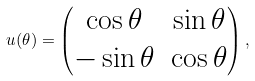Convert formula to latex. <formula><loc_0><loc_0><loc_500><loc_500>u ( \theta ) = \begin{pmatrix} \cos \theta & \sin \theta \\ - \sin \theta & \cos \theta \end{pmatrix} ,</formula> 